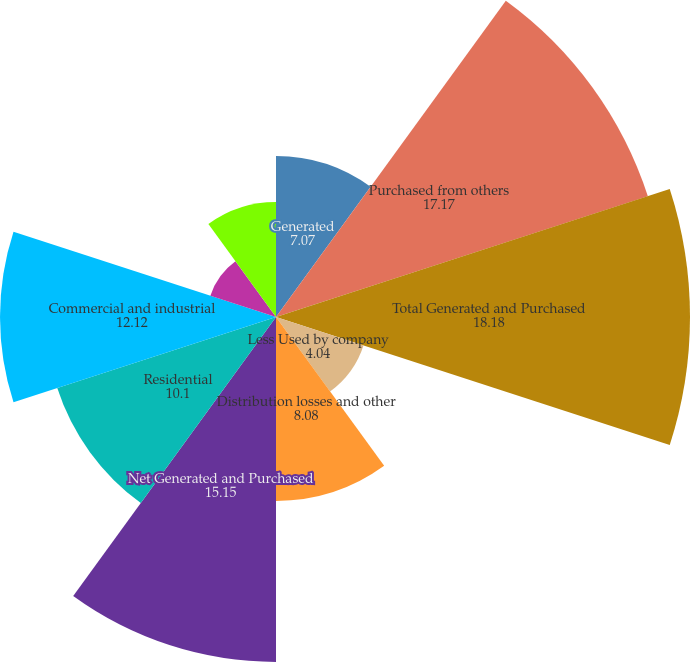<chart> <loc_0><loc_0><loc_500><loc_500><pie_chart><fcel>Generated<fcel>Purchased from others<fcel>Total Generated and Purchased<fcel>Less Used by company<fcel>Distribution losses and other<fcel>Net Generated and Purchased<fcel>Residential<fcel>Commercial and industrial<fcel>Railroads and railways<fcel>Public authorities<nl><fcel>7.07%<fcel>17.17%<fcel>18.18%<fcel>4.04%<fcel>8.08%<fcel>15.15%<fcel>10.1%<fcel>12.12%<fcel>3.03%<fcel>5.05%<nl></chart> 